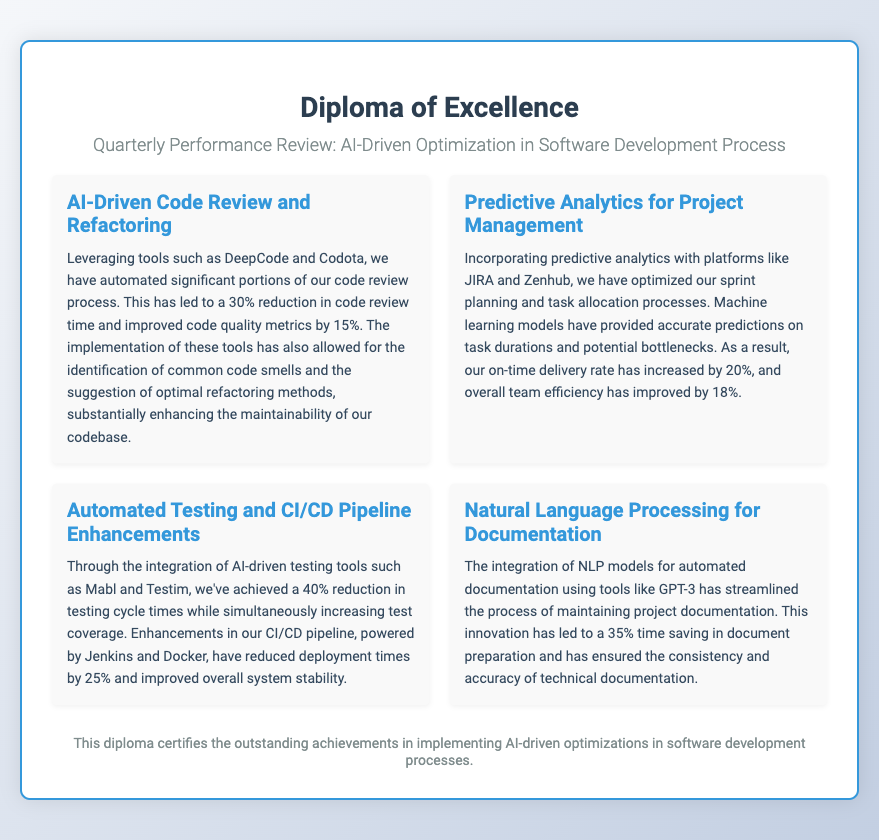What is the title of the diploma? The title of the diploma is prominently displayed as the first heading in the document, which identifies its purpose.
Answer: Diploma of Excellence What automation tool reduced the code review time? The document specifies a particular tool utilized to streamline the code review process, leading to efficiency gains.
Answer: DeepCode By how much did the on-time delivery rate increase? The document highlights a percentage increase in on-time delivery rate attributed to specific predictive analytics implementations.
Answer: 20% What was the reduction in testing cycle times? The diploma outlines improvements in testing efficiencies with specific numeric values indicating time savings.
Answer: 40% Which AI model was used for automated documentation? The document identifies a specific AI model that facilitated the documentation processes, contributing to overall efficiency.
Answer: GPT-3 What is the percentage improvement in team efficiency? The document quantifies the enhancement in team effectiveness as a direct result of optimization efforts through predictive analytics.
Answer: 18% What was the reduction in deployment times? The diploma states the percentage reduction achieved in deployment durations through pipeline enhancements.
Answer: 25% What is mentioned as a benefit of AI-driven code review? The document outlines specific improvements resulting from automated code reviews to highlight the advantages of this approach.
Answer: Improved code quality metrics by 15% What is the focus of the fourth section? The segmented content of the diploma specifies distinct focuses, with the fourth section concentrating on a particular optimization theme.
Answer: Natural Language Processing for Documentation 